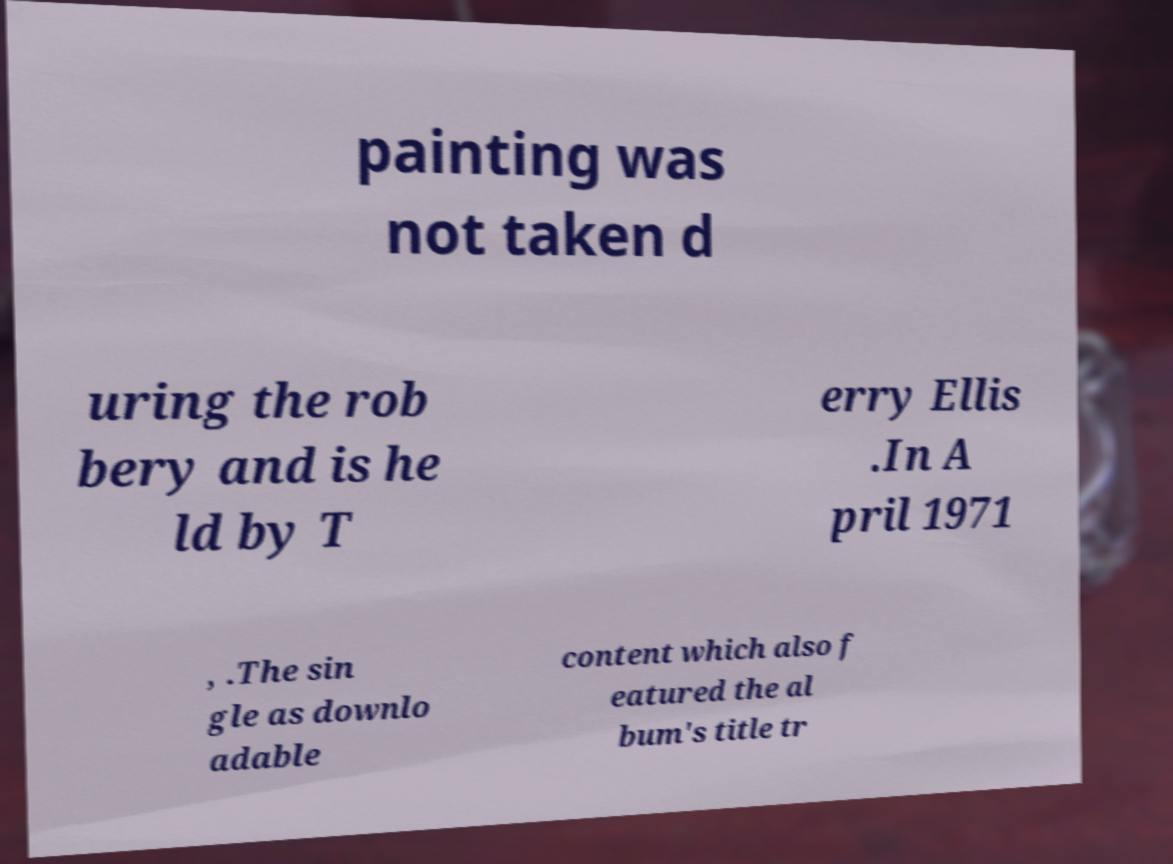For documentation purposes, I need the text within this image transcribed. Could you provide that? painting was not taken d uring the rob bery and is he ld by T erry Ellis .In A pril 1971 , .The sin gle as downlo adable content which also f eatured the al bum's title tr 